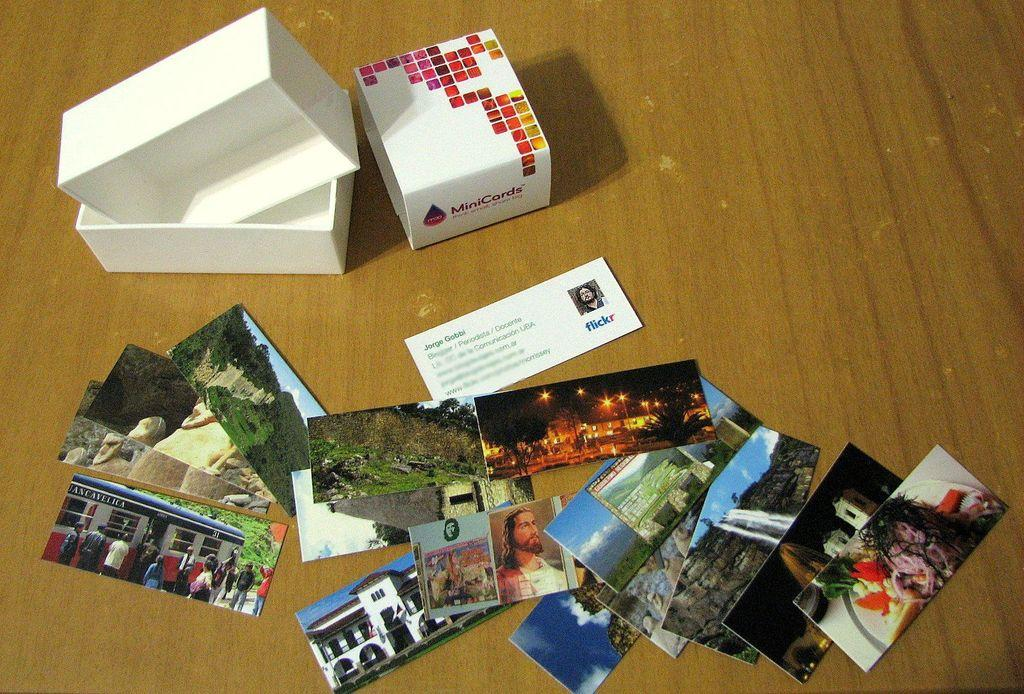What objects are visible in the image? There are photographs and a box visible in the image. Where are the photographs and the box located? The photographs and the box are kept on the floor. What type of bird can be seen eating a pancake in the image? There is no bird or pancake present in the image; it features photographs and a box on the floor. What is the name of the son in the image? There is no reference to a son in the image. 